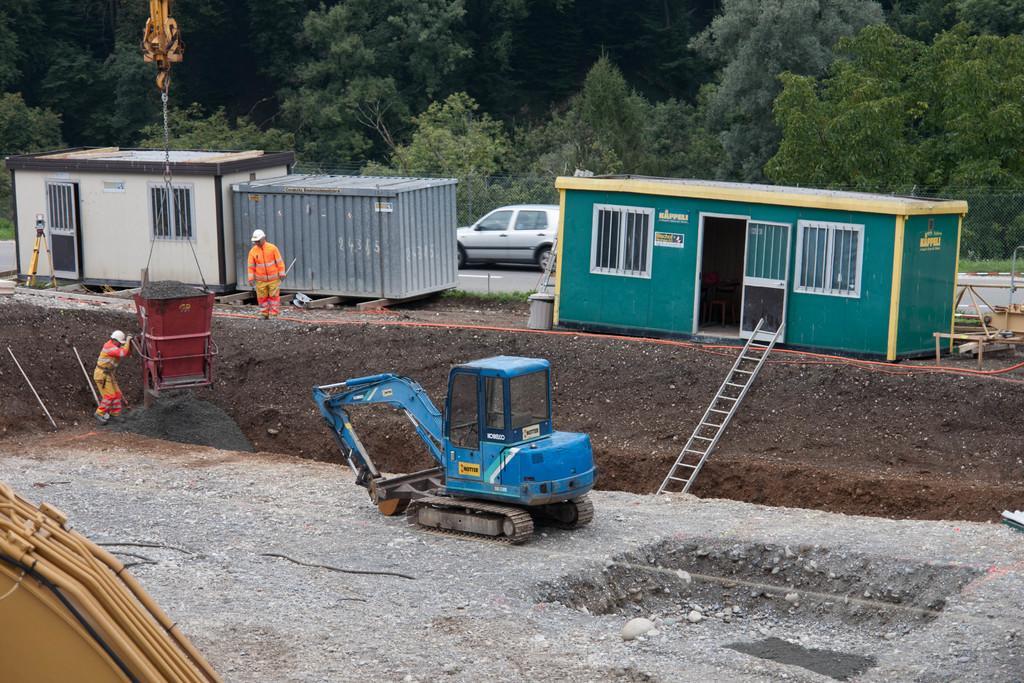Describe this image in one or two sentences. In the middle of the picture, we see a bulldozer in blue color. Beside that, we see a man is standing. Beside him, we see a red color tin which is hanged to the crane. Beside that, we see a man in orange jacket is standing. Beside him, we see a container and two houses in white and green color. We see a ladder. Behind him, we see a car. There are trees in the background. On the right side, we see a wooden thing. 